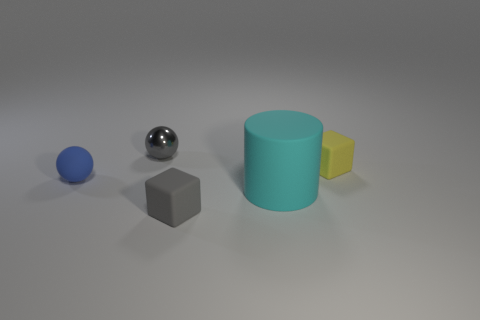Is there any other thing that has the same shape as the large cyan object?
Offer a very short reply. No. Are there any other things that have the same material as the tiny gray sphere?
Your response must be concise. No. The other thing that is the same color as the shiny thing is what size?
Offer a very short reply. Small. Are there more large matte objects right of the blue rubber object than tiny things that are right of the yellow rubber block?
Make the answer very short. Yes. Is there a small gray cube made of the same material as the small blue thing?
Provide a succinct answer. Yes. What is the thing that is both in front of the yellow matte cube and behind the big cyan cylinder made of?
Your answer should be compact. Rubber. What color is the cylinder?
Your answer should be very brief. Cyan. How many small gray matte objects are the same shape as the tiny yellow object?
Make the answer very short. 1. Are the small cube right of the big cyan object and the sphere that is in front of the small yellow rubber block made of the same material?
Provide a short and direct response. Yes. There is a matte cube in front of the block behind the tiny blue sphere; what size is it?
Ensure brevity in your answer.  Small. 